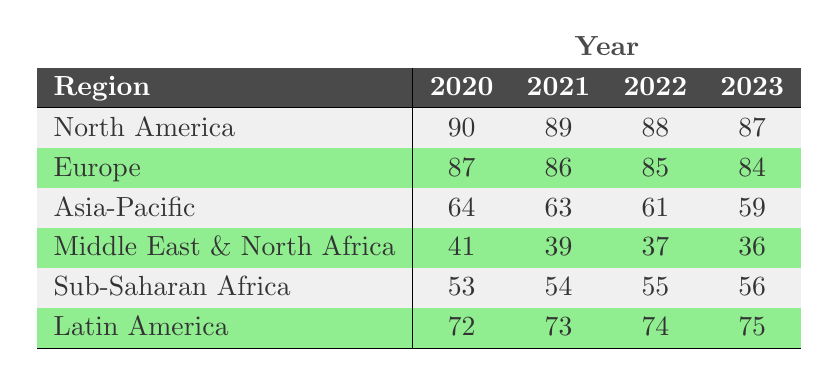What was the Global Freedom Index score for North America in 2021? According to the table, the score for North America in 2021 is found in the respective cell of the row for North America and the column for the year 2021, which shows a value of 89.
Answer: 89 What is the score for the Middle East & North Africa in 2023? The table indicates the score for the Middle East & North Africa for the year 2023, which is located at the intersection of the row for Middle East & North Africa and the column for the year 2023, showing a value of 36.
Answer: 36 How much did the Global Freedom Index score decrease for Europe from 2020 to 2023? The score for Europe in 2020 is 87, and in 2023 it is 84. To find the decrease, subtract the score in 2023 from that in 2020: 87 - 84 = 3.
Answer: 3 Was there an increase in the Global Freedom Index score for Latin America from 2021 to 2022? The score for Latin America in 2021 is 73, and in 2022 it is 74. Since 74 is greater than 73, there was an increase.
Answer: Yes Which region had the highest score in 2022? To determine the highest score in 2022, compare the scores for each region for that year: North America (88), Europe (85), Asia-Pacific (61), Middle East & North Africa (37), Sub-Saharan Africa (55), and Latin America (74). The highest score is 88 for North America.
Answer: North America What is the average Global Freedom Index score for Sub-Saharan Africa from 2020 to 2023? The scores for Sub-Saharan Africa are 53 (2020), 54 (2021), 55 (2022), and 56 (2023). To find the average, add these scores: 53 + 54 + 55 + 56 = 218. Then divide by 4: 218 / 4 = 54.5.
Answer: 54.5 Which region experienced a decrease in its Global Freedom Index score every year from 2020 to 2023? Analyze the scores for each region: North America decreased from 90 to 87, Europe from 87 to 84, Asia-Pacific from 64 to 59, Middle East & North Africa from 41 to 36. Both Europe and Asia-Pacific decreased every year.
Answer: Europe and Asia-Pacific Is it true that the Global Freedom Index score for North America was consistently above 85 from 2020 to 2023? Checking the scores: North America ranked 90 (2020), 89 (2021), 88 (2022), and 87 (2023). All these scores are above 85. Therefore, the statement is true.
Answer: True How much higher is the score for Latin America compared to that of the Middle East & North Africa in 2022? The score for Latin America in 2022 is 74, and for the Middle East & North Africa, it is 37. To find the difference: 74 - 37 = 37.
Answer: 37 